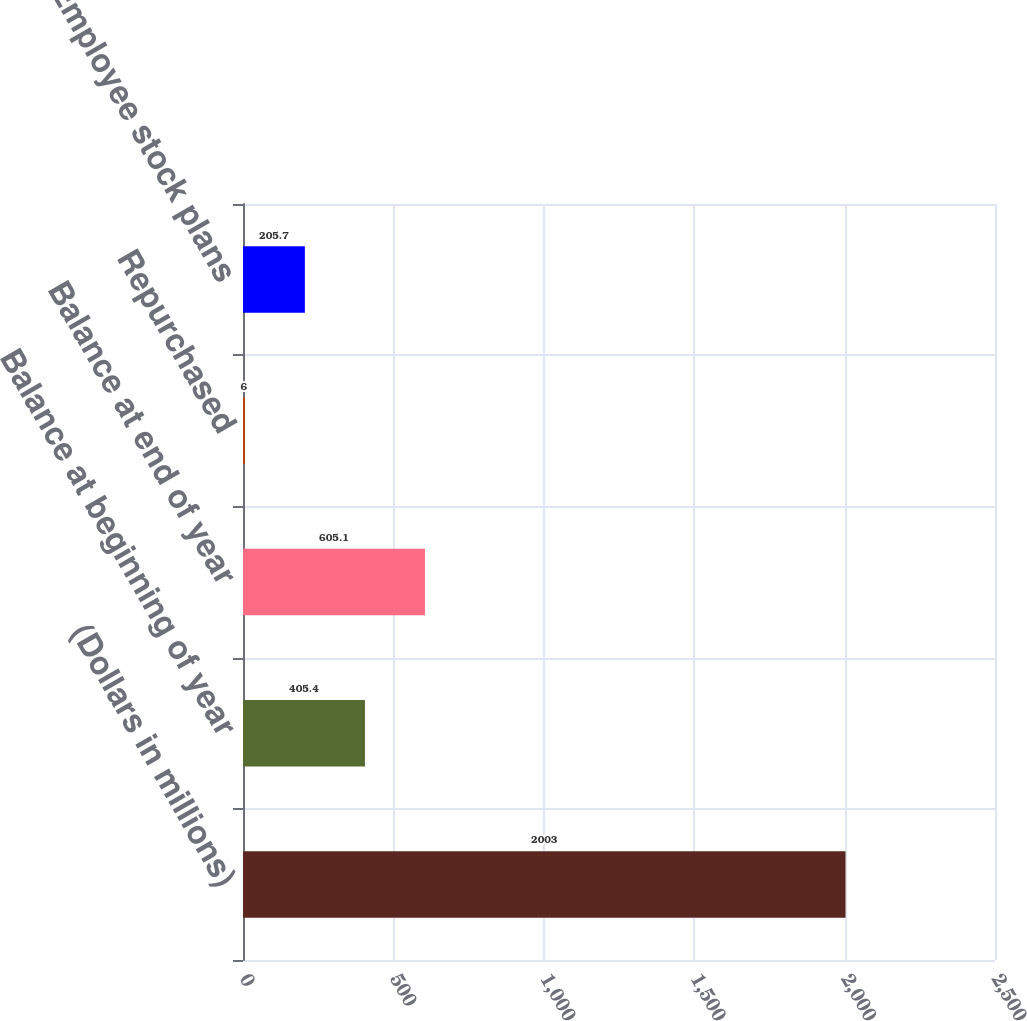<chart> <loc_0><loc_0><loc_500><loc_500><bar_chart><fcel>(Dollars in millions)<fcel>Balance at beginning of year<fcel>Balance at end of year<fcel>Repurchased<fcel>Employee stock plans<nl><fcel>2003<fcel>405.4<fcel>605.1<fcel>6<fcel>205.7<nl></chart> 